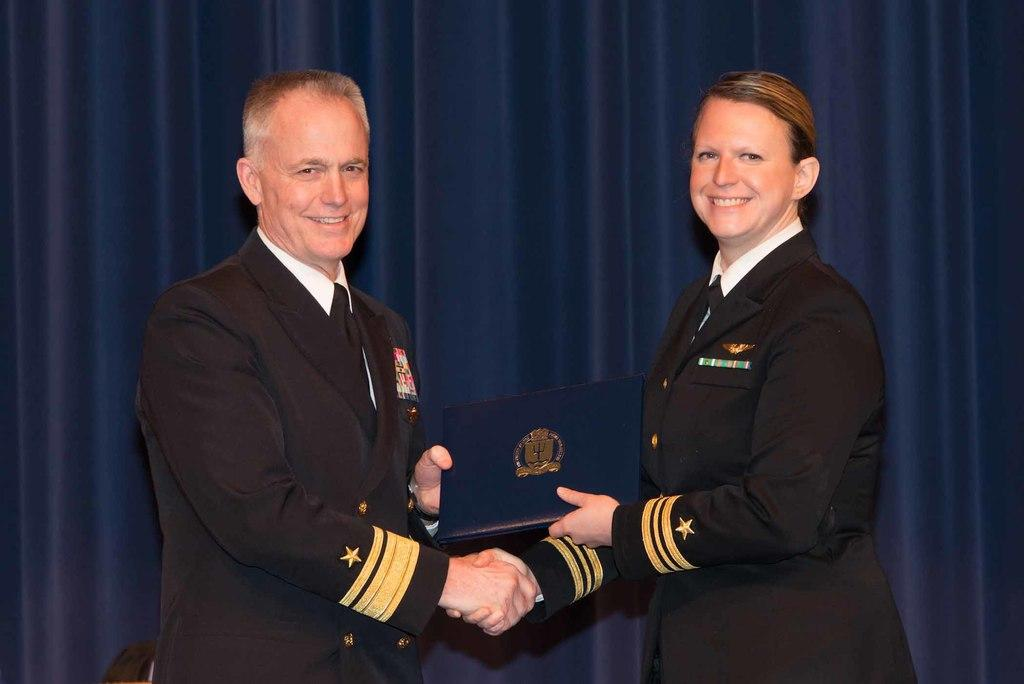How many people are in the image? There are two people in the image. What are the people doing in the image? The people are standing and smiling. What are the people holding in the image? The people are holding an object. What can be seen in the background of the image? There are blue curtains in the background of the image. What type of discussion is taking place between the people in the image? There is no discussion taking place in the image; the people are simply standing and smiling. What time of day is it in the image? The time of day cannot be determined from the image alone. --- Facts: 1. There is a car in the image. 2. The car is red. 3. The car has four wheels. 4. The car has a license plate. 5. The car is parked on the street. Absurd Topics: parrot, dance, ocean Conversation: What is the main subject of the image? The main subject of the image is a car. What color is the car? The car is red. How many wheels does the car have? The car has four wheels. Does the car have any identifying features? Yes, the car has a license plate. Where is the car located in the image? The car is parked on the street. Reasoning: Let's think step by step in order to produce the conversation. We start by identifying the main subject of the image, which is the car. Then, we describe the car's color, number of wheels, and the presence of a license plate. Finally, we mention the car's location, which is parked on the street. Absurd Question/Answer: Can you see a parrot dancing near the ocean in the image? No, there is no parrot, dancing, or ocean present in the image; it features a red car parked on the street. 